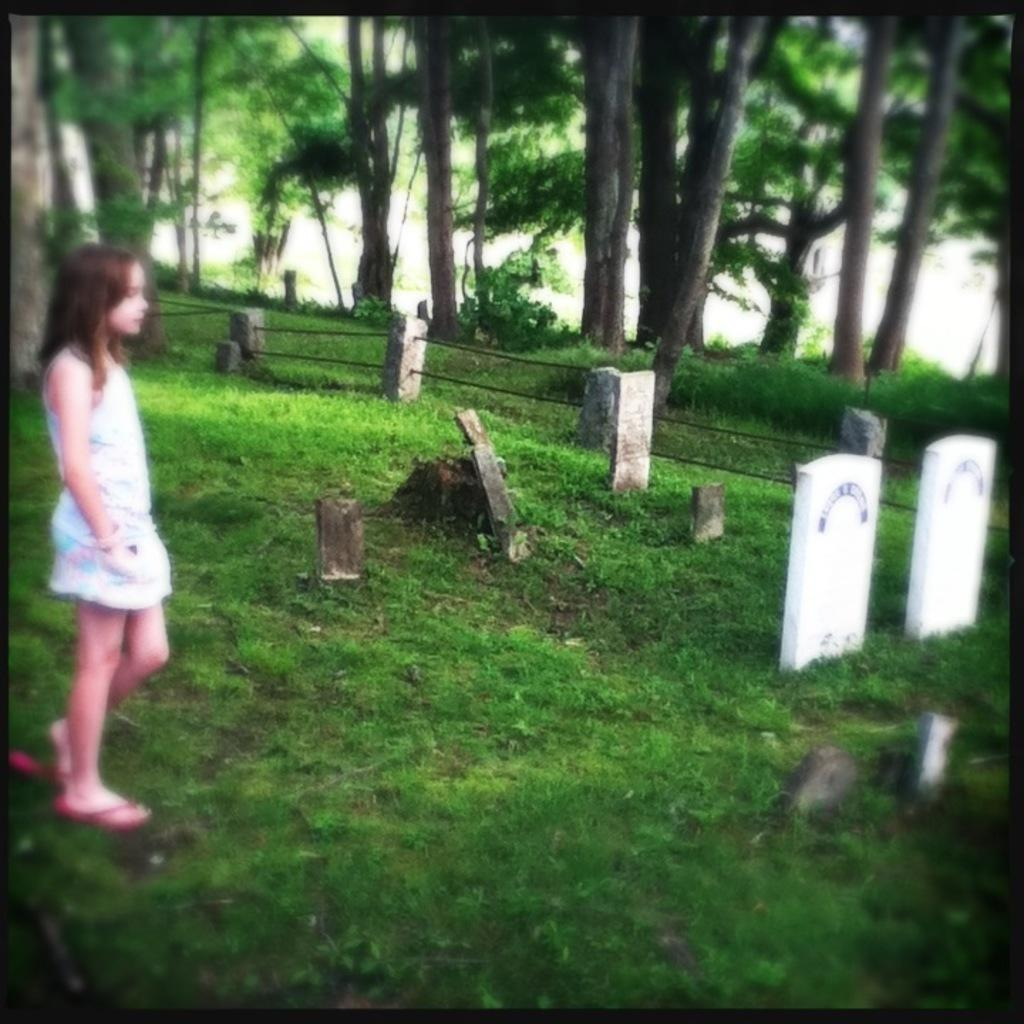What is the main subject of the image? There is a kid standing in the image. What type of terrain is visible at the bottom of the image? There is grass at the bottom of the image. What can be seen in the background of the image? There are trees in the background of the image. What type of road can be seen in the image? There is no road present in the image. What type of joke is the kid telling in the image? There is no indication of a joke being told in the image. 